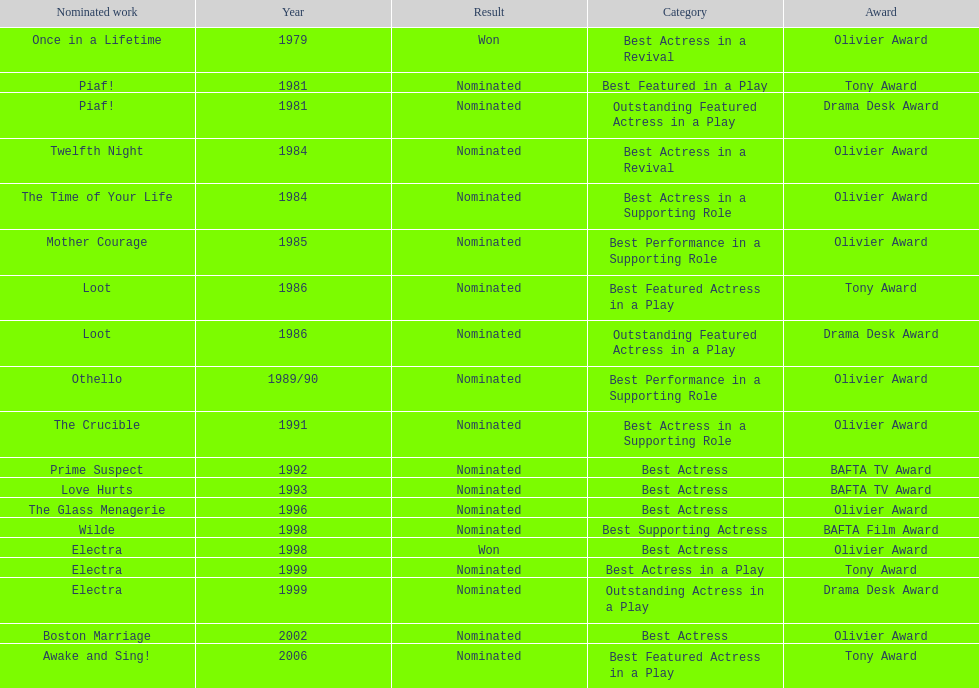Can you parse all the data within this table? {'header': ['Nominated work', 'Year', 'Result', 'Category', 'Award'], 'rows': [['Once in a Lifetime', '1979', 'Won', 'Best Actress in a Revival', 'Olivier Award'], ['Piaf!', '1981', 'Nominated', 'Best Featured in a Play', 'Tony Award'], ['Piaf!', '1981', 'Nominated', 'Outstanding Featured Actress in a Play', 'Drama Desk Award'], ['Twelfth Night', '1984', 'Nominated', 'Best Actress in a Revival', 'Olivier Award'], ['The Time of Your Life', '1984', 'Nominated', 'Best Actress in a Supporting Role', 'Olivier Award'], ['Mother Courage', '1985', 'Nominated', 'Best Performance in a Supporting Role', 'Olivier Award'], ['Loot', '1986', 'Nominated', 'Best Featured Actress in a Play', 'Tony Award'], ['Loot', '1986', 'Nominated', 'Outstanding Featured Actress in a Play', 'Drama Desk Award'], ['Othello', '1989/90', 'Nominated', 'Best Performance in a Supporting Role', 'Olivier Award'], ['The Crucible', '1991', 'Nominated', 'Best Actress in a Supporting Role', 'Olivier Award'], ['Prime Suspect', '1992', 'Nominated', 'Best Actress', 'BAFTA TV Award'], ['Love Hurts', '1993', 'Nominated', 'Best Actress', 'BAFTA TV Award'], ['The Glass Menagerie', '1996', 'Nominated', 'Best Actress', 'Olivier Award'], ['Wilde', '1998', 'Nominated', 'Best Supporting Actress', 'BAFTA Film Award'], ['Electra', '1998', 'Won', 'Best Actress', 'Olivier Award'], ['Electra', '1999', 'Nominated', 'Best Actress in a Play', 'Tony Award'], ['Electra', '1999', 'Nominated', 'Outstanding Actress in a Play', 'Drama Desk Award'], ['Boston Marriage', '2002', 'Nominated', 'Best Actress', 'Olivier Award'], ['Awake and Sing!', '2006', 'Nominated', 'Best Featured Actress in a Play', 'Tony Award']]} What year was prime suspects nominated for the bafta tv award? 1992. 